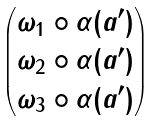Convert formula to latex. <formula><loc_0><loc_0><loc_500><loc_500>\begin{pmatrix} \omega _ { 1 } \circ \alpha ( a ^ { \prime } ) \\ \omega _ { 2 } \circ \alpha ( a ^ { \prime } ) \\ \omega _ { 3 } \circ \alpha ( a ^ { \prime } ) \\ \end{pmatrix}</formula> 